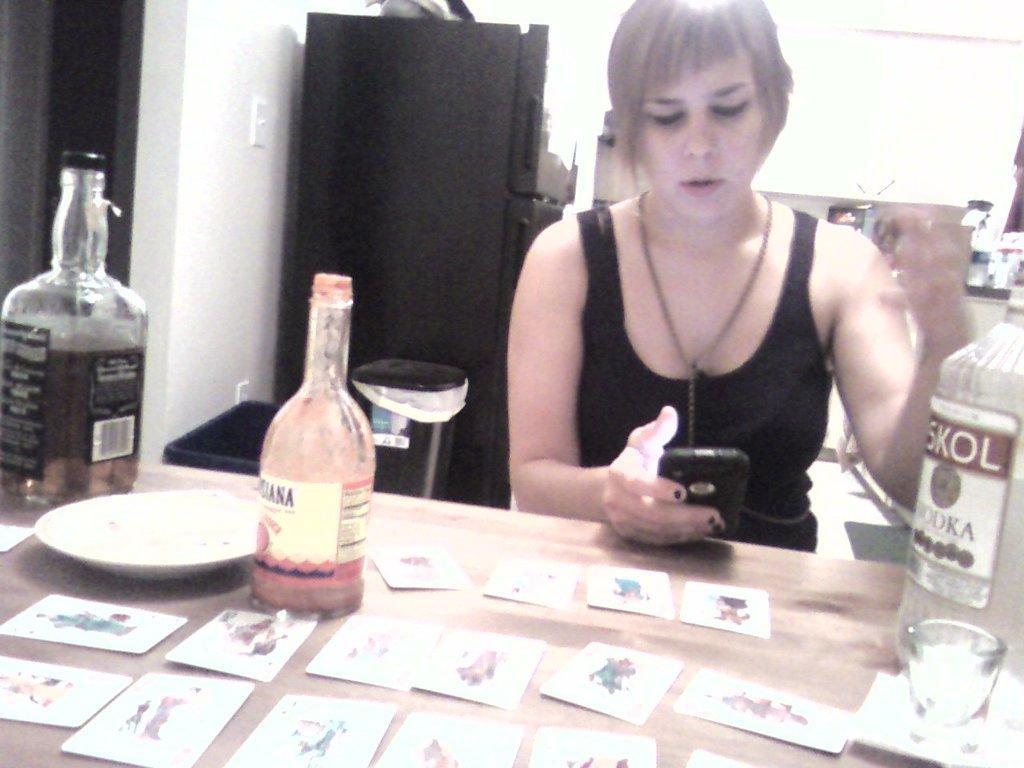In one or two sentences, can you explain what this image depicts? A woman is sitting on the chair and looking into the mobile phone. There are wine bottles on the table. 